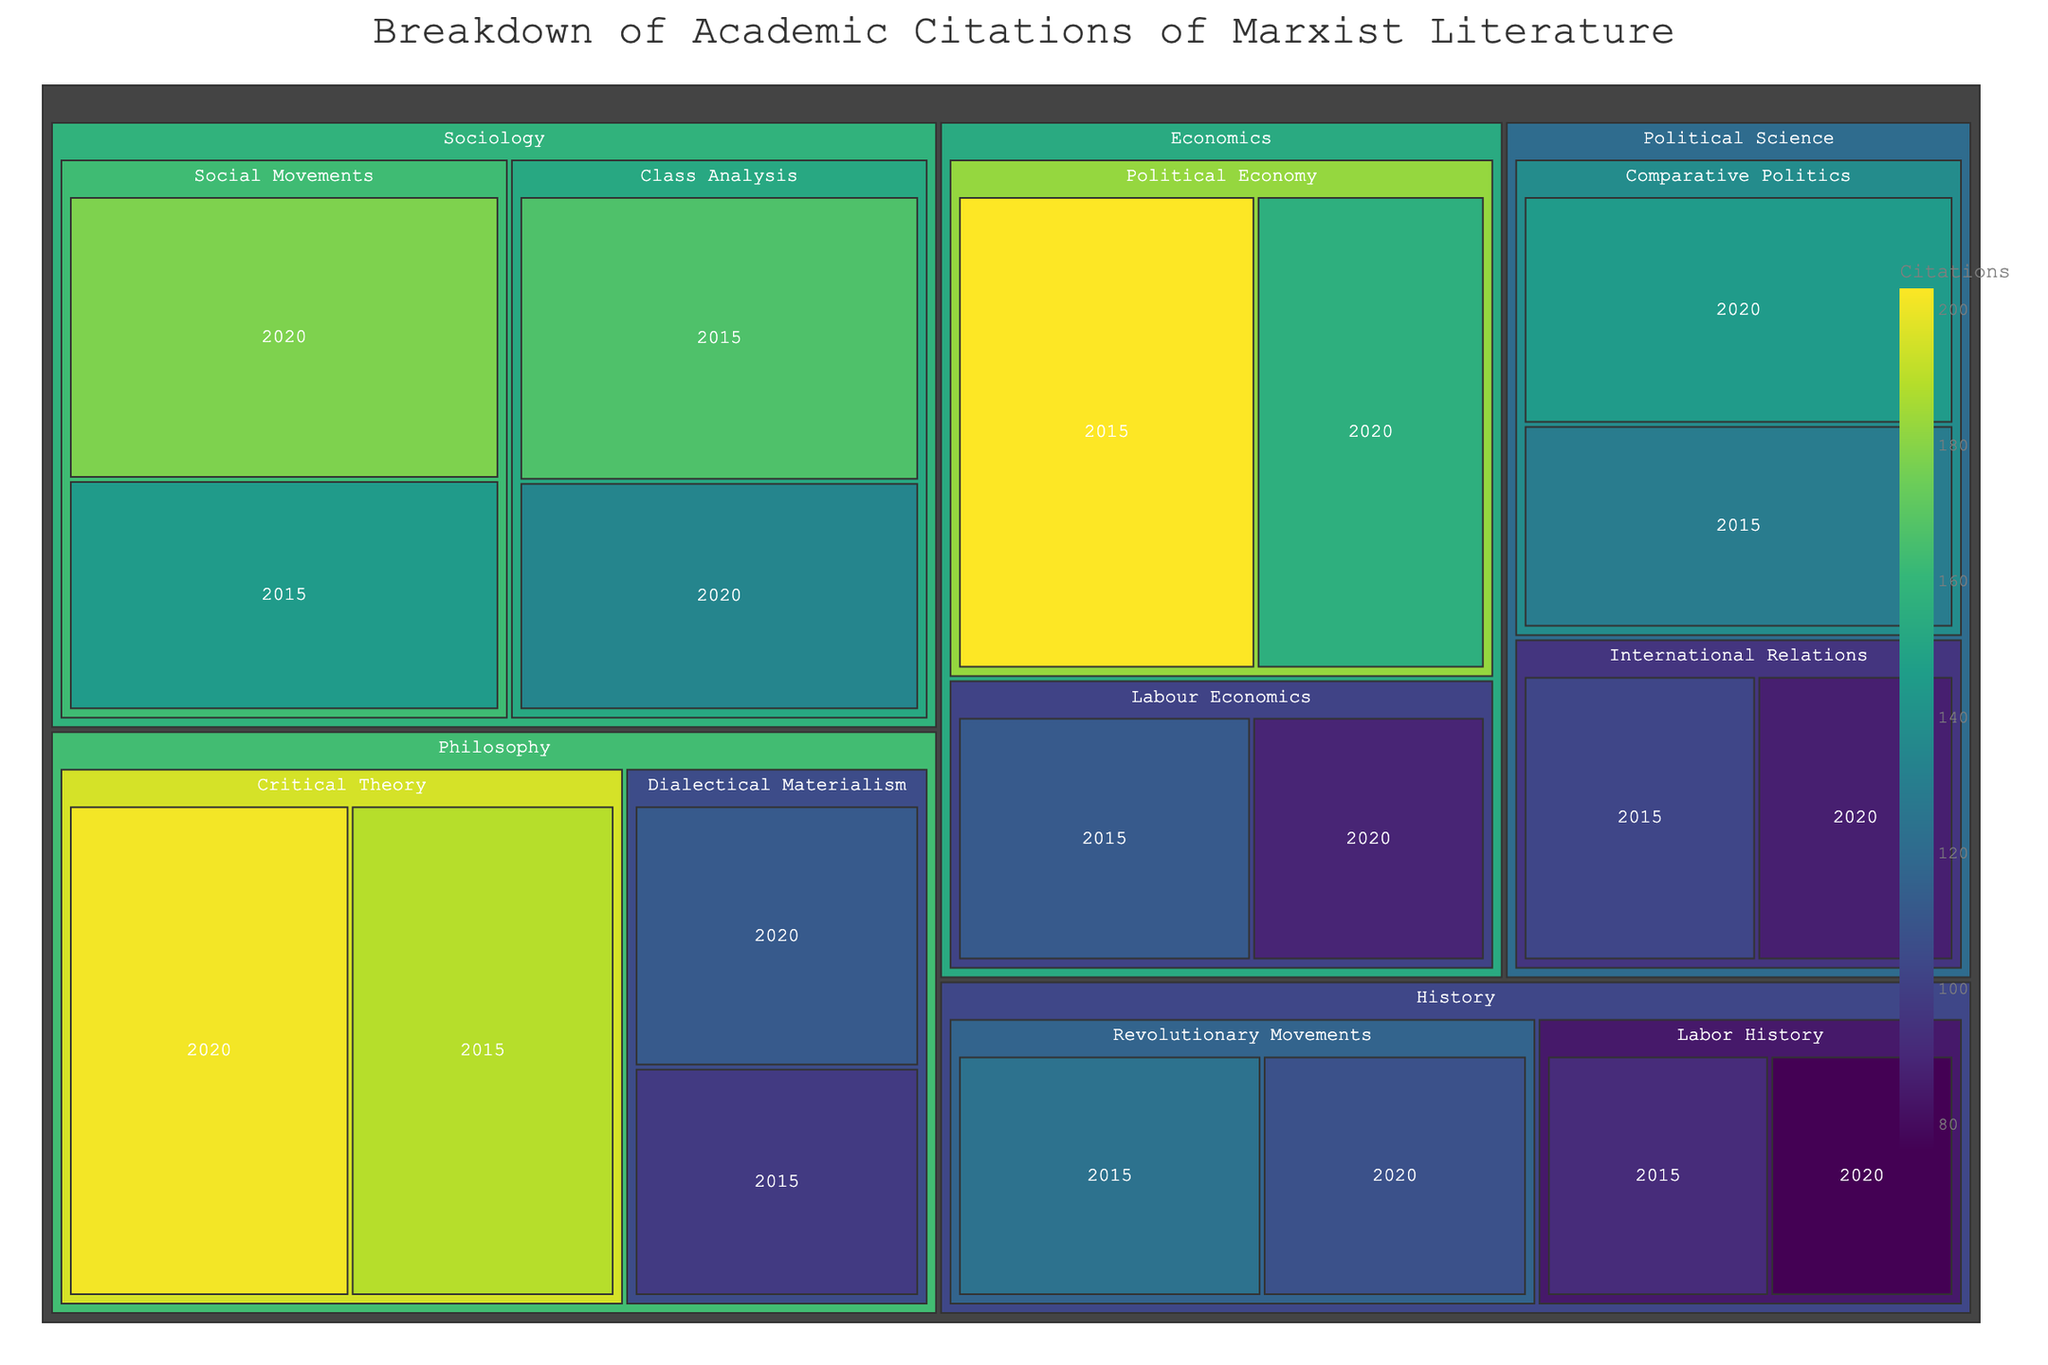What is the title of the figure? The title is usually located at the top center of the figure. In this case, it reads "Breakdown of Academic Citations of Marxist Literature".
Answer: Breakdown of Academic Citations of Marxist Literature Which field of study had the most citations in 2020? By examining the colored blocks representing the different fields, we can see that Philosophy (particularly "Critical Theory") had the highest number of citations in 2020.
Answer: Philosophy How many citations did the "Comparative Politics" subfield receive in 2015 and 2020 combined? Locate the blocks for "Comparative Politics" under "Political Science" and sum the citations for both years. In 2015: 129 citations, and in 2020: 145 citations. Combined: 129 + 145 = 274 citations.
Answer: 274 Which subfield within Sociology had the highest citations in 2020, and how many citations did it receive? Looking at the blocks under the Sociology field for 2020, "Social Movements" received the most citations with a count of 178.
Answer: Social Movements, 178 How did citations for "Labour Economics" in Economics change from 2015 to 2020? Compare the citation count for "Labour Economics" in both years: 2015 had 112 citations, and 2020 had 89 citations. The difference indicates a decrease by 112 - 89 = 23 citations.
Answer: Decreased by 23 In terms of total citations, was "Class Analysis" in Sociology more cited in 2015 or 2020? Compare the citation numbers for "Class Analysis" in both years: 2015 had 167 citations, while 2020 had 134 citations. Thus, it was more cited in 2015.
Answer: 2015 What is the total number of citations for articles in the Philosophy field across both years? Sum the citations for all subfields under Philosophy for both years: Critical Theory (2015: 189, 2020: 201), Dialectical Materialism (2015: 98, 2020: 112). Total = 189 + 201 + 98 + 112 = 600 citations.
Answer: 600 Which subfield in History had a higher number of citations in 2020: "Labor History" or "Revolutionary Movements"? Compare the 2020 citation numbers for "Labor History" (76 citations) and "Revolutionary Movements" (108 citations). "Revolutionary Movements" had more citations at 108.
Answer: Revolutionary Movements Between 2015 and 2020, which field showed an increase in the number of citations for "International Relations" under Political Science? Compare the citation counts: 103 in 2015 and 87 in 2020. Since 87 is less than 103, there was a decrease, not an increase.
Answer: None (Decrease) What is the difference in citations between "Political Economy" and "Labour Economics" within Economics for the year 2020? Compare the 2020 citations for "Political Economy" (156 citations) and "Labour Economics" (89 citations). The difference is 156 - 89 = 67 citations.
Answer: 67 